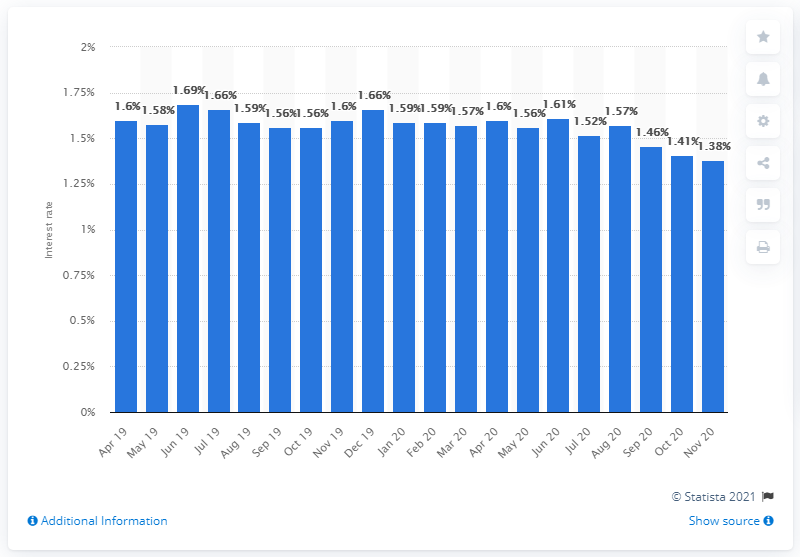Identify some key points in this picture. The initial rate fixation for mortgages was five years or more, and the interest rate was 1.38%. 